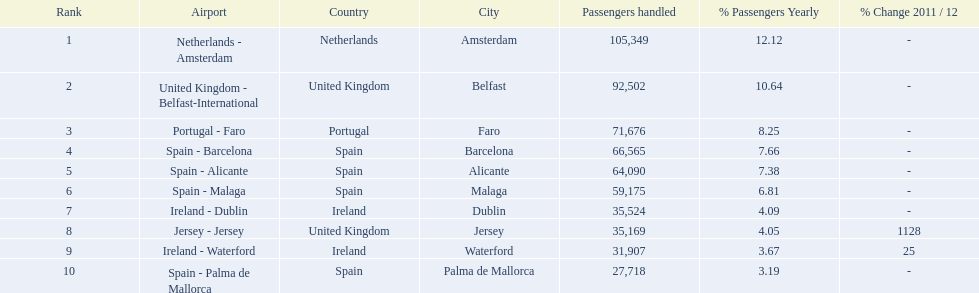What are the names of all the airports? Netherlands - Amsterdam, United Kingdom - Belfast-International, Portugal - Faro, Spain - Barcelona, Spain - Alicante, Spain - Malaga, Ireland - Dublin, Jersey - Jersey, Ireland - Waterford, Spain - Palma de Mallorca. Of these, what are all the passenger counts? 105,349, 92,502, 71,676, 66,565, 64,090, 59,175, 35,524, 35,169, 31,907, 27,718. Of these, which airport had more passengers than the united kingdom? Netherlands - Amsterdam. 